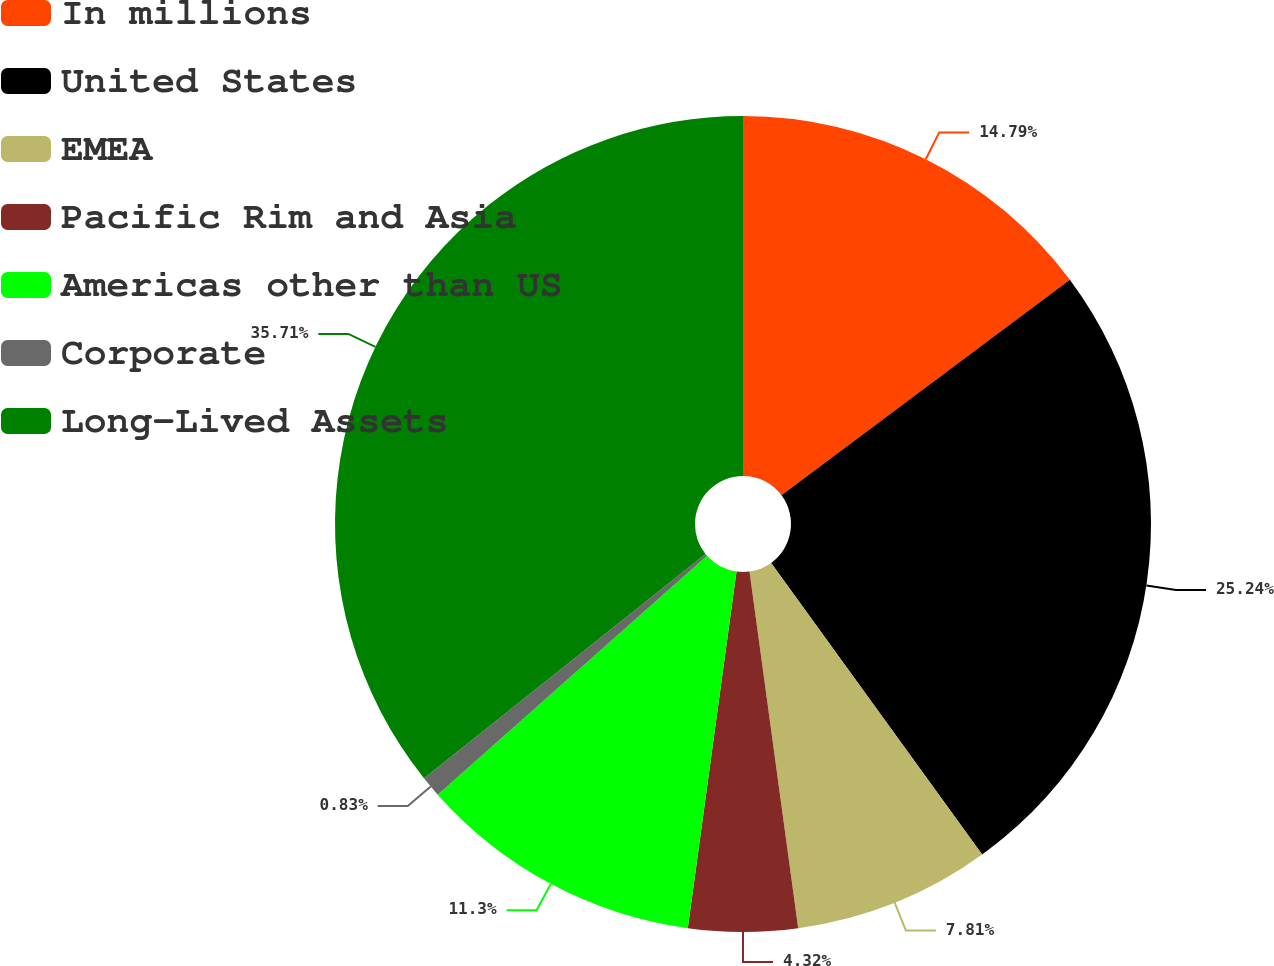<chart> <loc_0><loc_0><loc_500><loc_500><pie_chart><fcel>In millions<fcel>United States<fcel>EMEA<fcel>Pacific Rim and Asia<fcel>Americas other than US<fcel>Corporate<fcel>Long-Lived Assets<nl><fcel>14.79%<fcel>25.25%<fcel>7.81%<fcel>4.32%<fcel>11.3%<fcel>0.83%<fcel>35.72%<nl></chart> 